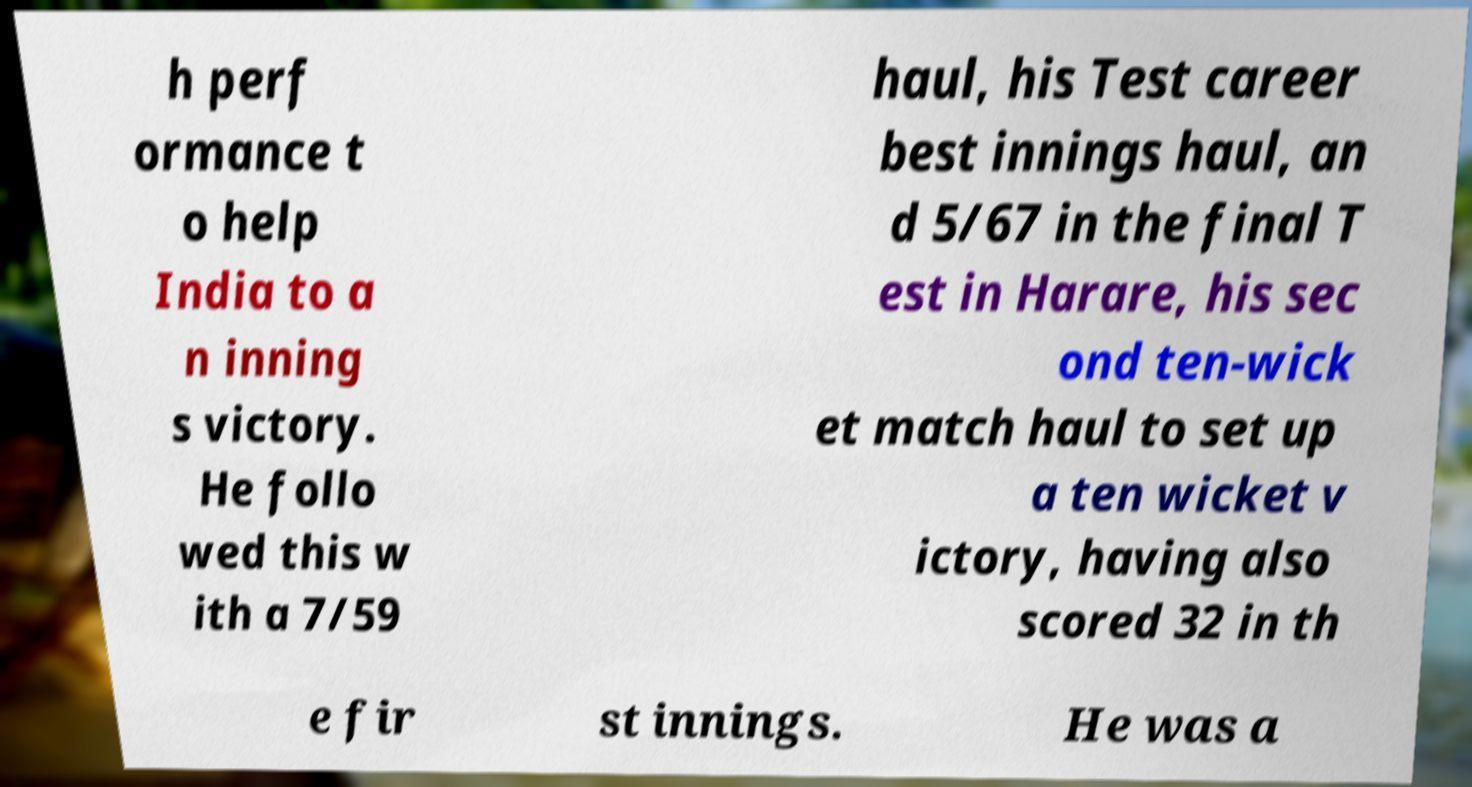Could you assist in decoding the text presented in this image and type it out clearly? h perf ormance t o help India to a n inning s victory. He follo wed this w ith a 7/59 haul, his Test career best innings haul, an d 5/67 in the final T est in Harare, his sec ond ten-wick et match haul to set up a ten wicket v ictory, having also scored 32 in th e fir st innings. He was a 